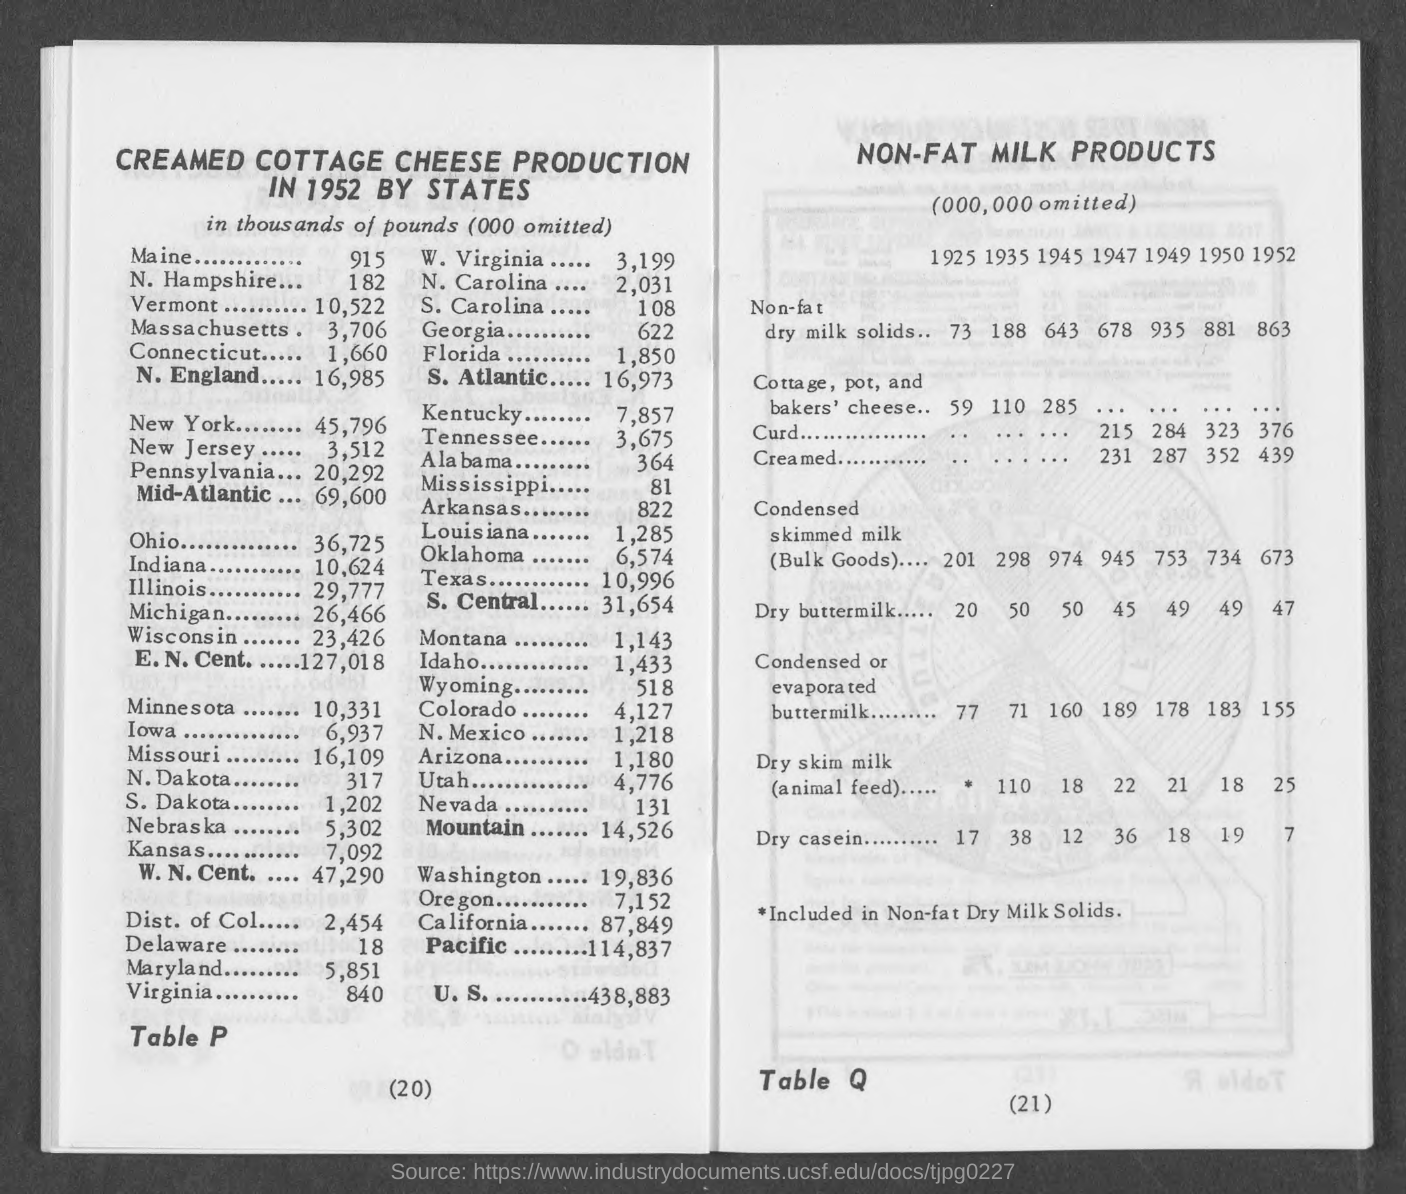How much milk in thousands of pounds does maine produce?
Your answer should be very brief. 915. How much milk in thousands of pounds does n. hampshire produce?
Give a very brief answer. 182. How much milk in thousands of pounds does vermont produce?
Offer a very short reply. 10,522. How much milk in thousands of pounds does massachusetts produce?
Your answer should be very brief. 3,706. How much milk in thousands of pounds does connecticut produce?
Your answer should be compact. 1,660. How much milk in thousands of pounds does new york produce?
Offer a very short reply. 45,796. How much milk in thousands of pounds does  new jersey produce?
Ensure brevity in your answer.  3,512. How much milk in thousands of pounds does pennsylvania produce?
Provide a short and direct response. 20,292. How much milk in thousands of pounds does ohio produce?
Ensure brevity in your answer.  36,725. How much milk in thousands of pounds does indiana produce?
Your answer should be compact. 10,624. 